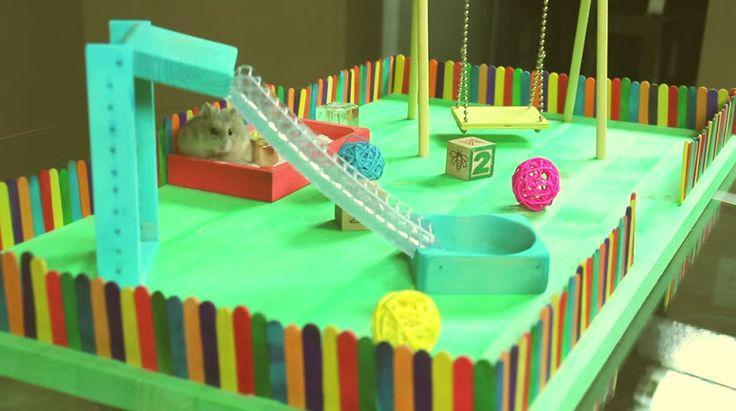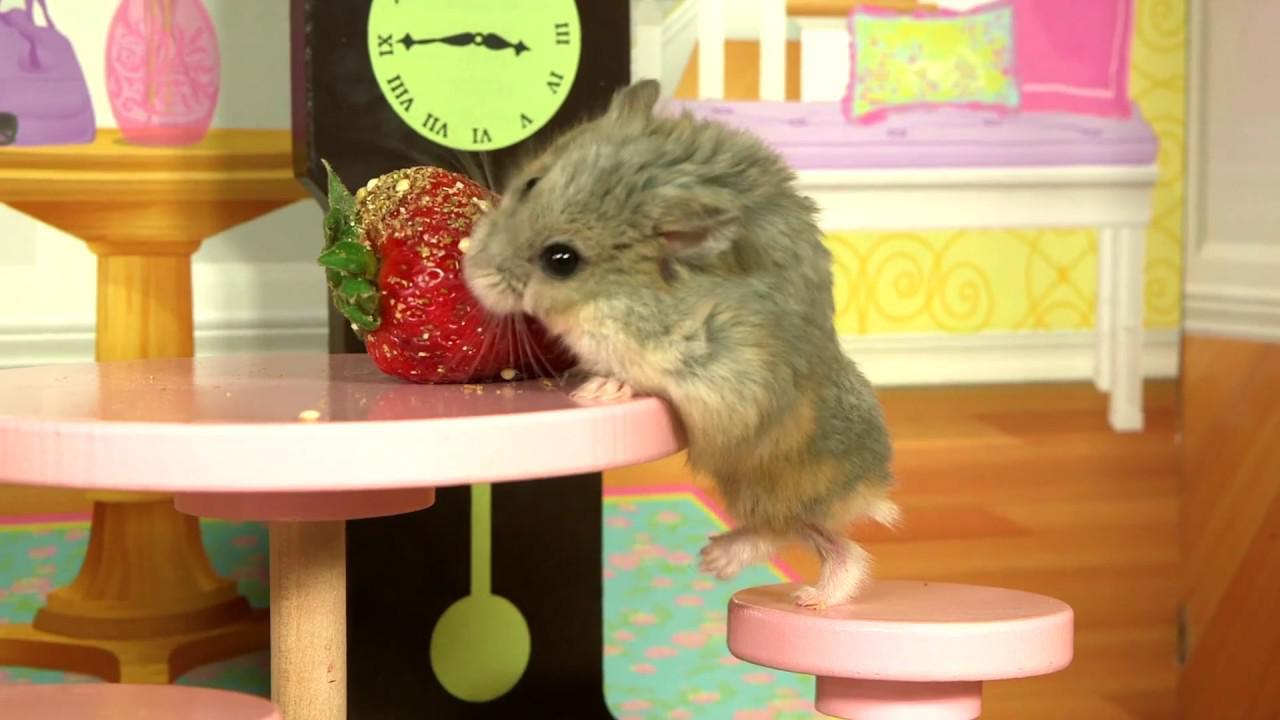The first image is the image on the left, the second image is the image on the right. For the images displayed, is the sentence "Two hamsters are on swings." factually correct? Answer yes or no. No. The first image is the image on the left, the second image is the image on the right. Considering the images on both sides, is "Th e image on the left contains two hamsters." valid? Answer yes or no. No. 